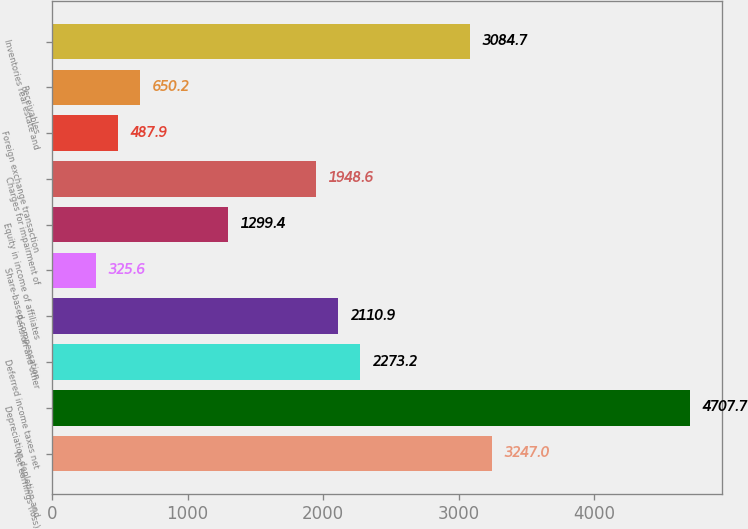<chart> <loc_0><loc_0><loc_500><loc_500><bar_chart><fcel>Net earnings (loss)<fcel>Depreciation depletion and<fcel>Deferred income taxes net<fcel>Pension and other<fcel>Share-based compensation<fcel>Equity in income of affiliates<fcel>Charges for impairment of<fcel>Foreign exchange transaction<fcel>Receivables<fcel>Inventories real estate and<nl><fcel>3247<fcel>4707.7<fcel>2273.2<fcel>2110.9<fcel>325.6<fcel>1299.4<fcel>1948.6<fcel>487.9<fcel>650.2<fcel>3084.7<nl></chart> 